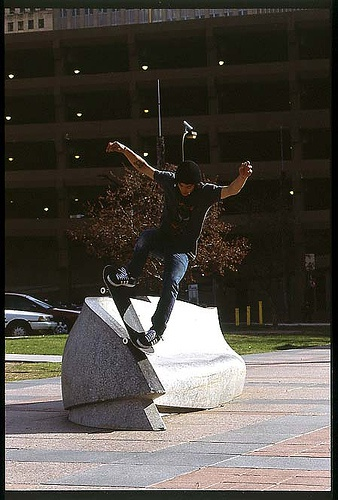Describe the objects in this image and their specific colors. I can see bench in black, white, gray, and darkgray tones, people in black, maroon, gray, and white tones, car in black, gray, darkgray, and lavender tones, skateboard in black, darkgray, gray, and lightgray tones, and car in black, gray, white, and darkgray tones in this image. 